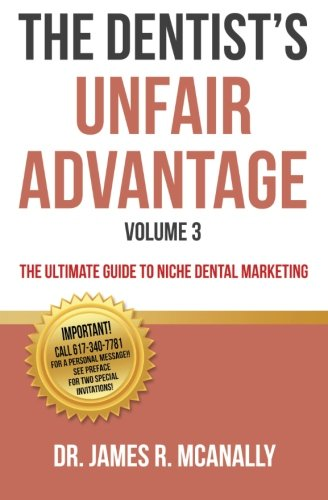What color scheme is used on the cover of this book? The book's cover utilizes a primary color scheme of red and white, which captures attention and emphasizes the text effectively. 